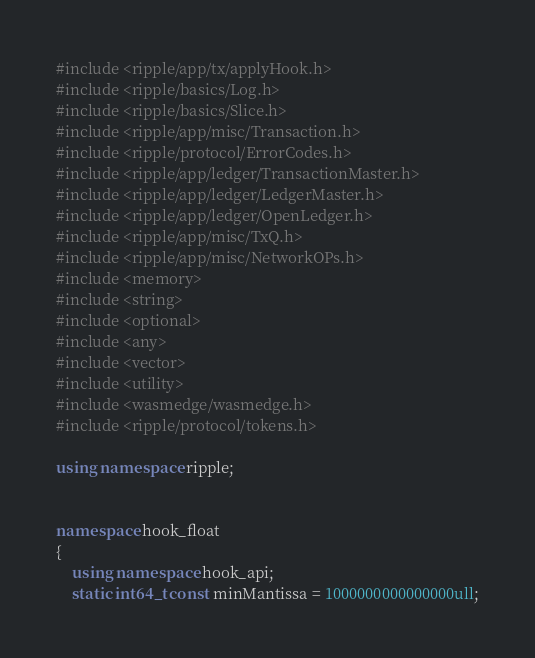<code> <loc_0><loc_0><loc_500><loc_500><_C++_>#include <ripple/app/tx/applyHook.h>
#include <ripple/basics/Log.h>
#include <ripple/basics/Slice.h>
#include <ripple/app/misc/Transaction.h>
#include <ripple/protocol/ErrorCodes.h>
#include <ripple/app/ledger/TransactionMaster.h>
#include <ripple/app/ledger/LedgerMaster.h>
#include <ripple/app/ledger/OpenLedger.h>
#include <ripple/app/misc/TxQ.h>
#include <ripple/app/misc/NetworkOPs.h>
#include <memory>
#include <string>
#include <optional>
#include <any>
#include <vector>
#include <utility>
#include <wasmedge/wasmedge.h>
#include <ripple/protocol/tokens.h>

using namespace ripple;


namespace hook_float
{
    using namespace hook_api;
    static int64_t const minMantissa = 1000000000000000ull;</code> 